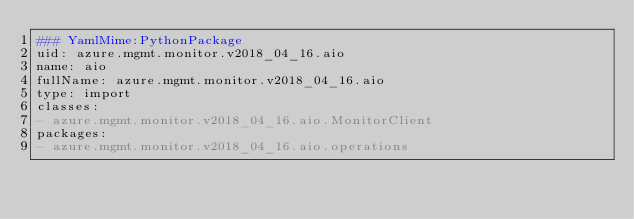<code> <loc_0><loc_0><loc_500><loc_500><_YAML_>### YamlMime:PythonPackage
uid: azure.mgmt.monitor.v2018_04_16.aio
name: aio
fullName: azure.mgmt.monitor.v2018_04_16.aio
type: import
classes:
- azure.mgmt.monitor.v2018_04_16.aio.MonitorClient
packages:
- azure.mgmt.monitor.v2018_04_16.aio.operations
</code> 